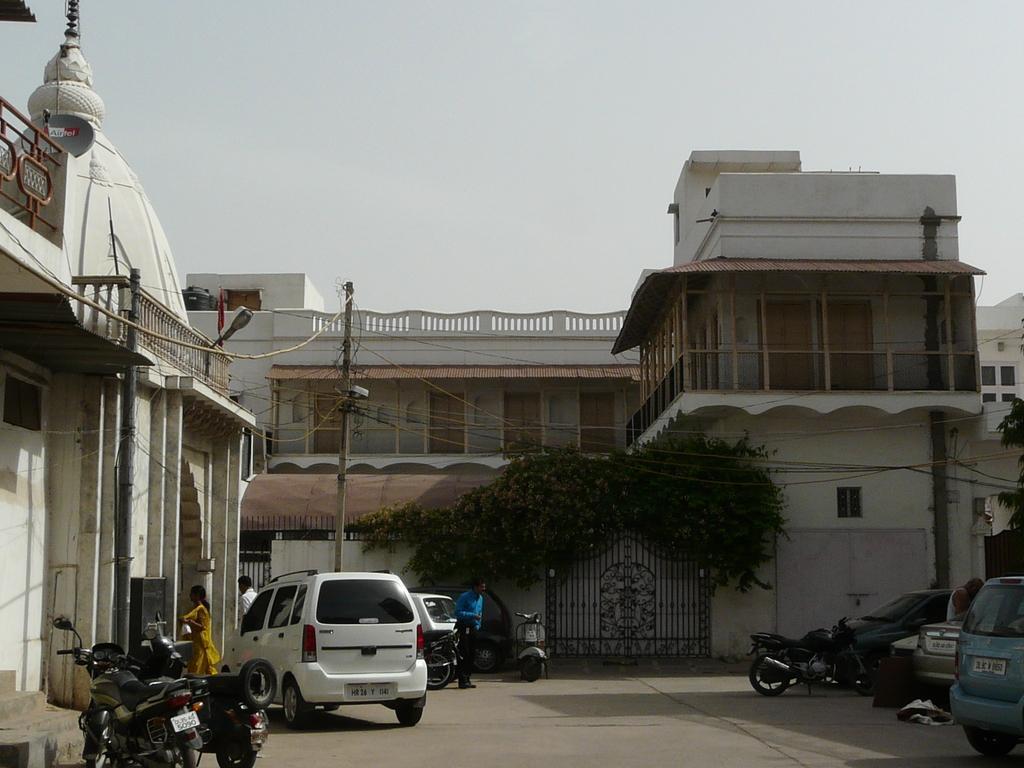In one or two sentences, can you explain what this image depicts? In this image I can see few people, vehicles and many motorbikes on the road. In the background I can see the pole, plants and buildings. I can also see the sky in the back. 